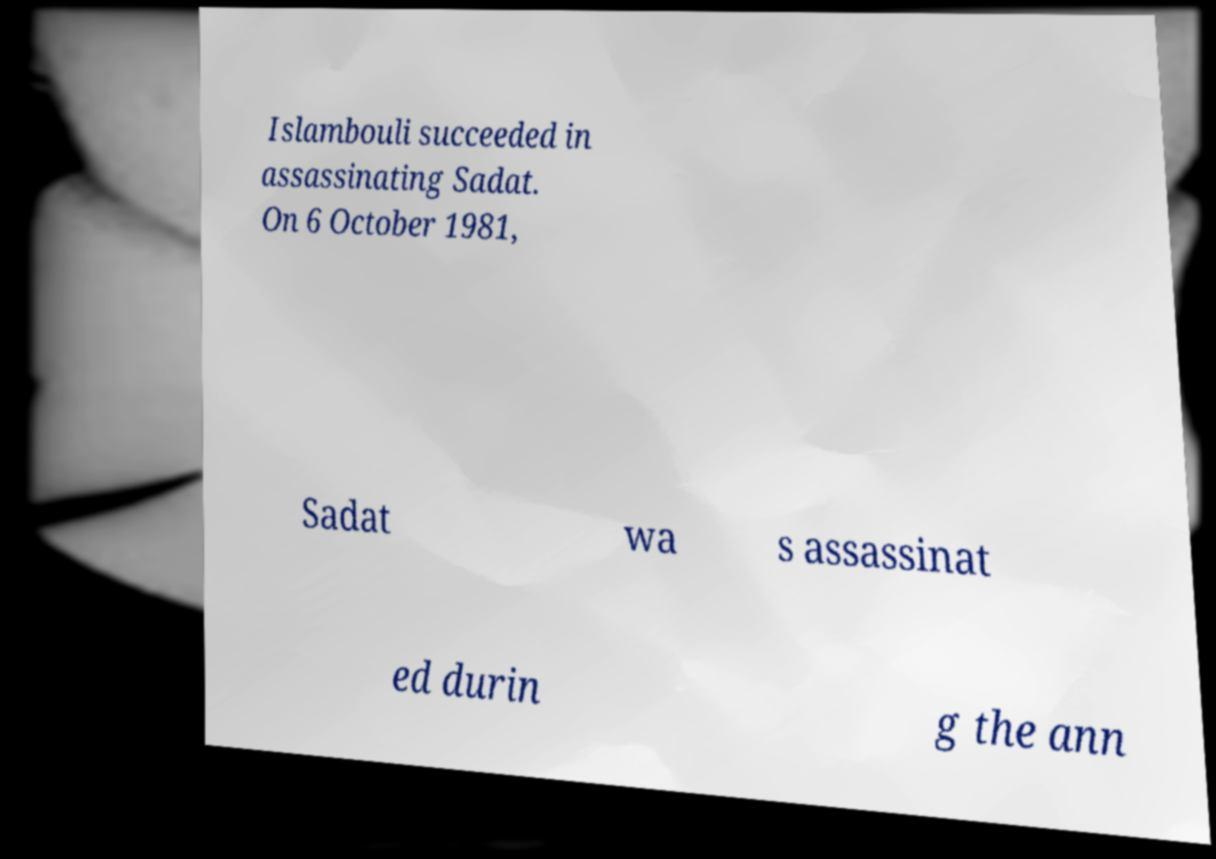What messages or text are displayed in this image? I need them in a readable, typed format. Islambouli succeeded in assassinating Sadat. On 6 October 1981, Sadat wa s assassinat ed durin g the ann 